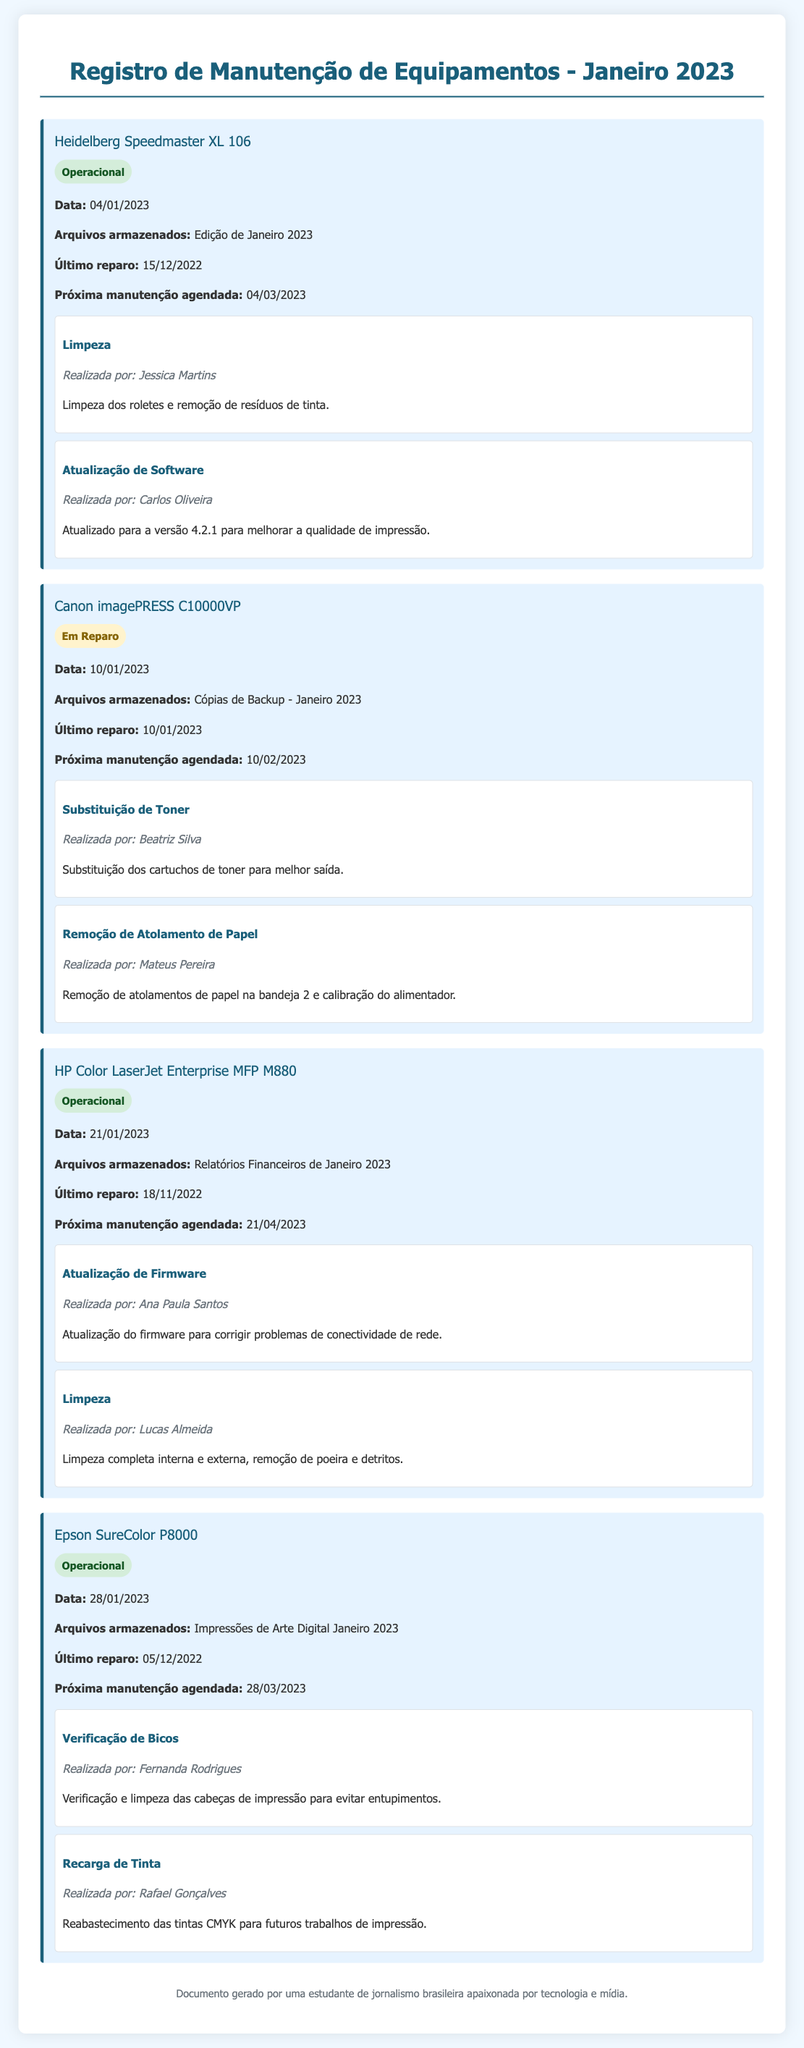Qual é o status da Heidelberg Speedmaster XL 106? A Heidelberg Speedmaster XL 106 está classificada como "Operacional" no documento.
Answer: Operacional Quem realizou a limpeza da Heidelberg Speedmaster XL 106? A limpeza foi realizada por Jessica Martins, conforme registrado nas atividades de manutenção.
Answer: Jessica Martins Quando foi a última manutenção da Canon imagePRESS C10000VP? A última manutenção da Canon imagePRESS C10000VP foi feita em 10/01/2023.
Answer: 10/01/2023 Qual é a próxima manutenção agendada para a HP Color LaserJet Enterprise MFP M880? A próxima manutenção da HP Color LaserJet Enterprise MFP M880 está agendada para 21/04/2023.
Answer: 21/04/2023 Quantas atividades de manutenção foram registradas para a Epson SureColor P8000? Foram registradas duas atividades de manutenção para a Epson SureColor P8000.
Answer: Duas Quem atualizou o firmware da HP Color LaserJet Enterprise MFP M880? A atualização do firmware foi realizada por Ana Paula Santos.
Answer: Ana Paula Santos Qual foi a atividade realizada na Canon imagePRESS C10000VP relacionada à substituição de componentes? A atividade foi a substituição dos cartuchos de toner.
Answer: Substituição de Toner Qual o motivo da manutenção registrada para a Canon imagePRESS C10000VP? O motivo da manutenção foi a substituição de toner e remoção de atolamentos de papel.
Answer: Substituição de toner e remoção de atolamentos de papel Qual é o documento gerado por? O documento foi gerado por uma estudante de jornalismo brasileira apaixonada por tecnologia e mídia.
Answer: Uma estudante de jornalismo brasileira 